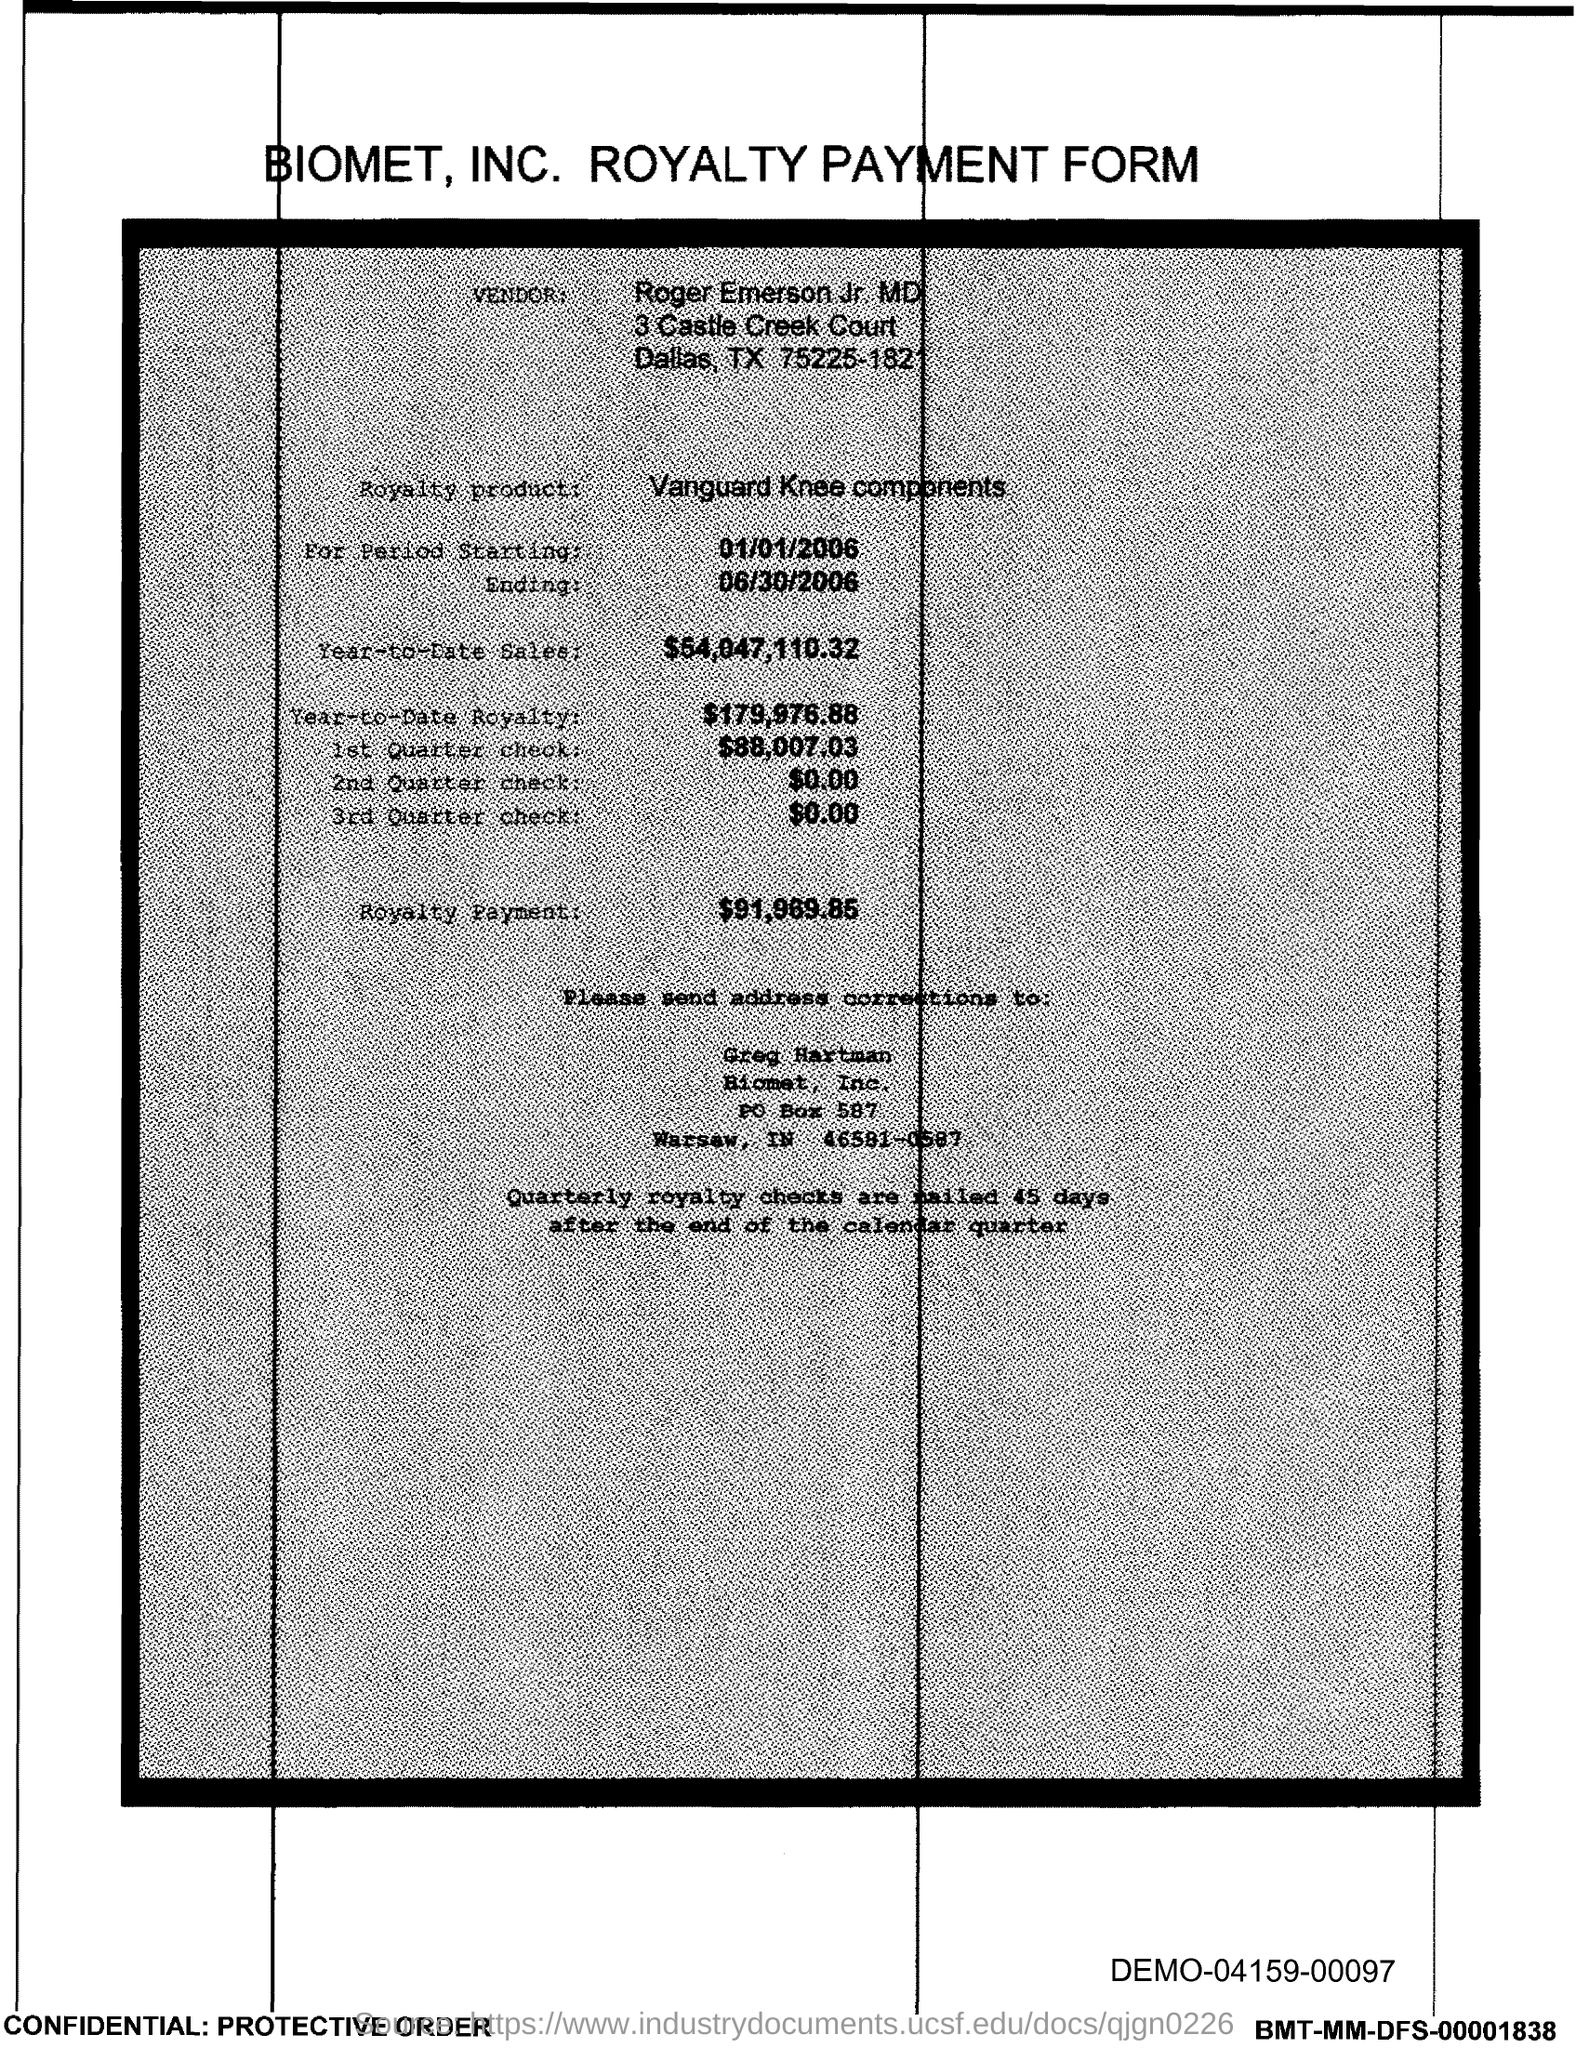Give some essential details in this illustration. The amount mentioned in the form for the 2nd Quarter check is $0.00. The amount of the 1st quarter check mentioned in the form is $88,007.03. The amount listed on the 3rd Quarter check form is $0.00. The royalty payment for the product mentioned in the form is $91,969.85. The year-to-date royalty for the product is $179,976.88. 